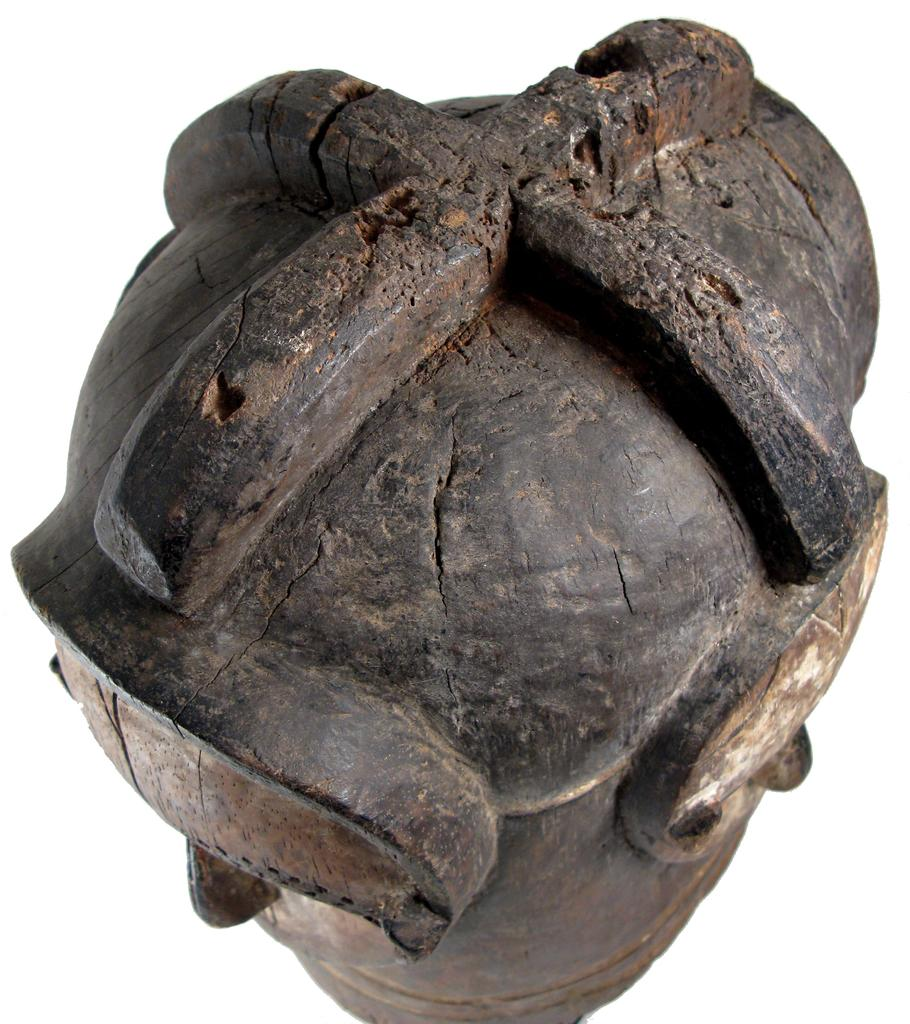What type of material is the object in the image made of? The object in the image is made of wood. What color is the wooden object? The wooden object is in brown color. What color is the background of the image? The background of the image is white. What type of lead can be seen in the image? There is no lead present in the image; it features a wooden object. Is there a birthday celebration happening in the image? There is no indication of a birthday celebration in the image. 